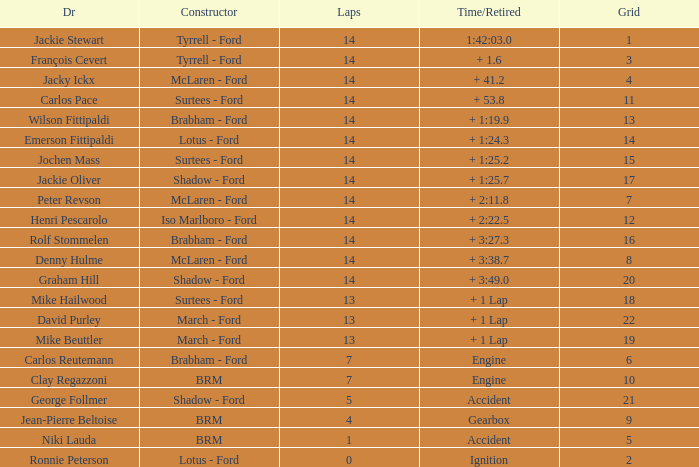What grad has a Time/Retired of + 1:24.3? 14.0. 